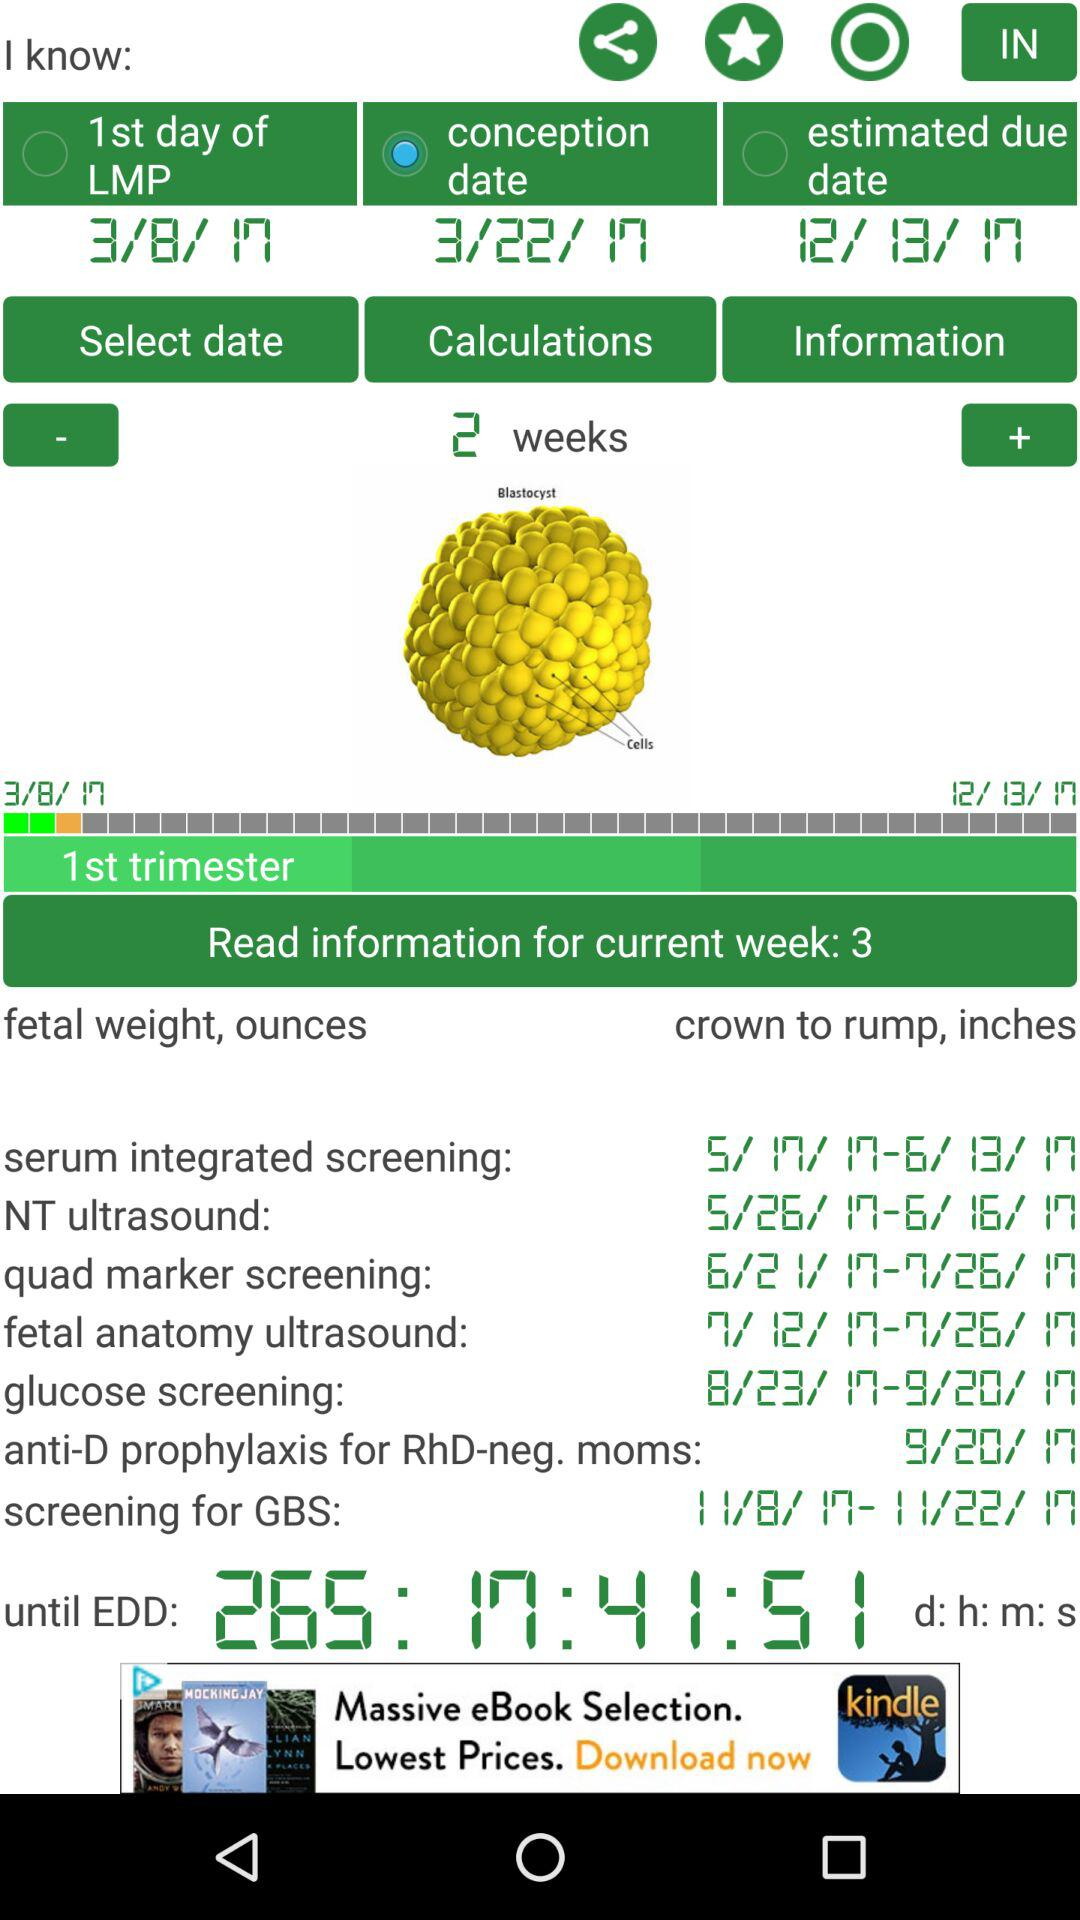What is the conception date? The conception date is March 22, 2017. 